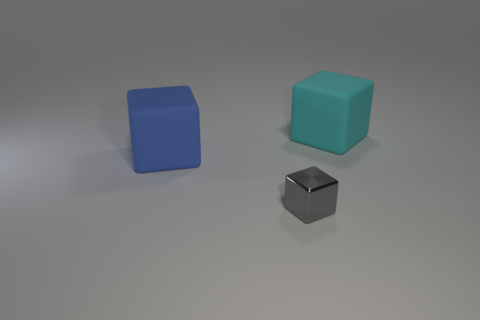Add 3 big blue objects. How many objects exist? 6 Add 1 small gray blocks. How many small gray blocks are left? 2 Add 3 gray metallic things. How many gray metallic things exist? 4 Subtract 1 cyan blocks. How many objects are left? 2 Subtract all tiny cubes. Subtract all big blue matte cubes. How many objects are left? 1 